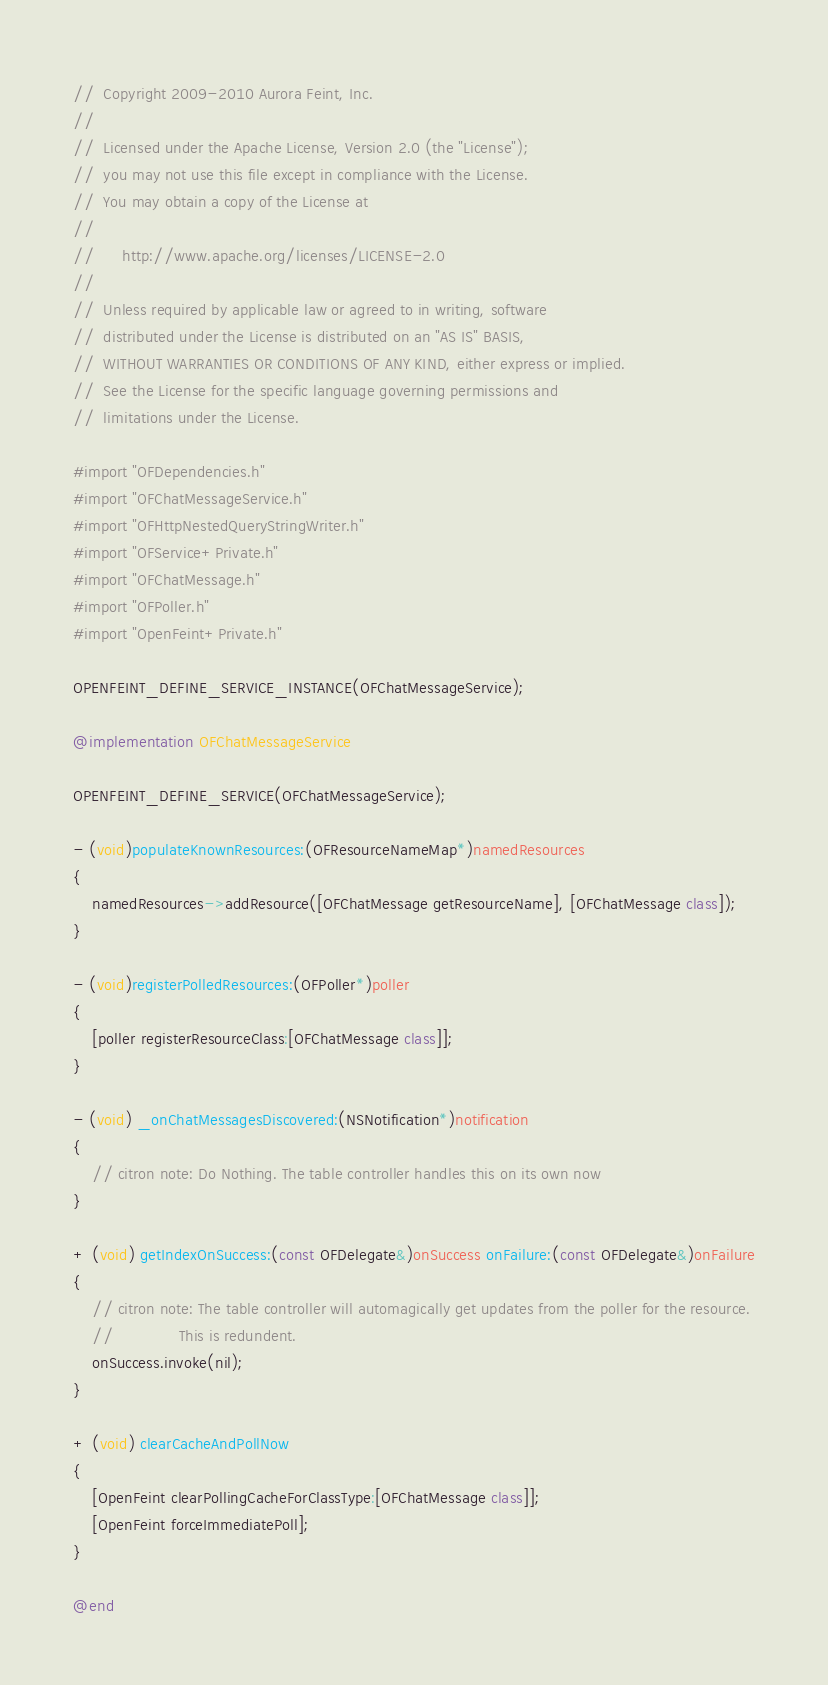Convert code to text. <code><loc_0><loc_0><loc_500><loc_500><_ObjectiveC_>//  Copyright 2009-2010 Aurora Feint, Inc.
// 
//  Licensed under the Apache License, Version 2.0 (the "License");
//  you may not use this file except in compliance with the License.
//  You may obtain a copy of the License at
//  
//  	http://www.apache.org/licenses/LICENSE-2.0
//  	
//  Unless required by applicable law or agreed to in writing, software
//  distributed under the License is distributed on an "AS IS" BASIS,
//  WITHOUT WARRANTIES OR CONDITIONS OF ANY KIND, either express or implied.
//  See the License for the specific language governing permissions and
//  limitations under the License.

#import "OFDependencies.h"
#import "OFChatMessageService.h"
#import "OFHttpNestedQueryStringWriter.h"
#import "OFService+Private.h"
#import "OFChatMessage.h"
#import "OFPoller.h"
#import "OpenFeint+Private.h"

OPENFEINT_DEFINE_SERVICE_INSTANCE(OFChatMessageService);

@implementation OFChatMessageService

OPENFEINT_DEFINE_SERVICE(OFChatMessageService);

- (void)populateKnownResources:(OFResourceNameMap*)namedResources
{
	namedResources->addResource([OFChatMessage getResourceName], [OFChatMessage class]);
}

- (void)registerPolledResources:(OFPoller*)poller
{
	[poller registerResourceClass:[OFChatMessage class]];
}

- (void) _onChatMessagesDiscovered:(NSNotification*)notification
{
	// citron note: Do Nothing. The table controller handles this on its own now
}

+ (void) getIndexOnSuccess:(const OFDelegate&)onSuccess onFailure:(const OFDelegate&)onFailure
{
	// citron note: The table controller will automagically get updates from the poller for the resource.
	//				This is redundent.
	onSuccess.invoke(nil);
}

+ (void) clearCacheAndPollNow
{
	[OpenFeint clearPollingCacheForClassType:[OFChatMessage class]];
	[OpenFeint forceImmediatePoll];
}

@end
</code> 